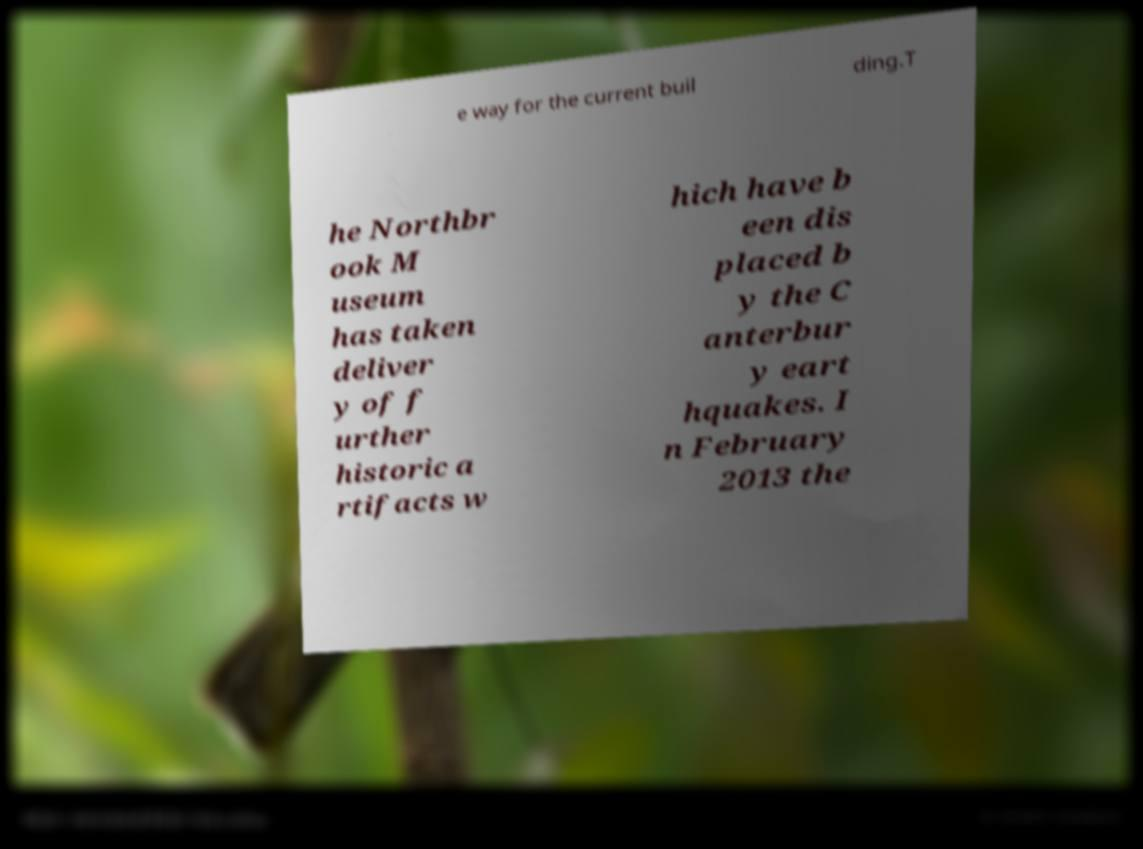There's text embedded in this image that I need extracted. Can you transcribe it verbatim? e way for the current buil ding.T he Northbr ook M useum has taken deliver y of f urther historic a rtifacts w hich have b een dis placed b y the C anterbur y eart hquakes. I n February 2013 the 